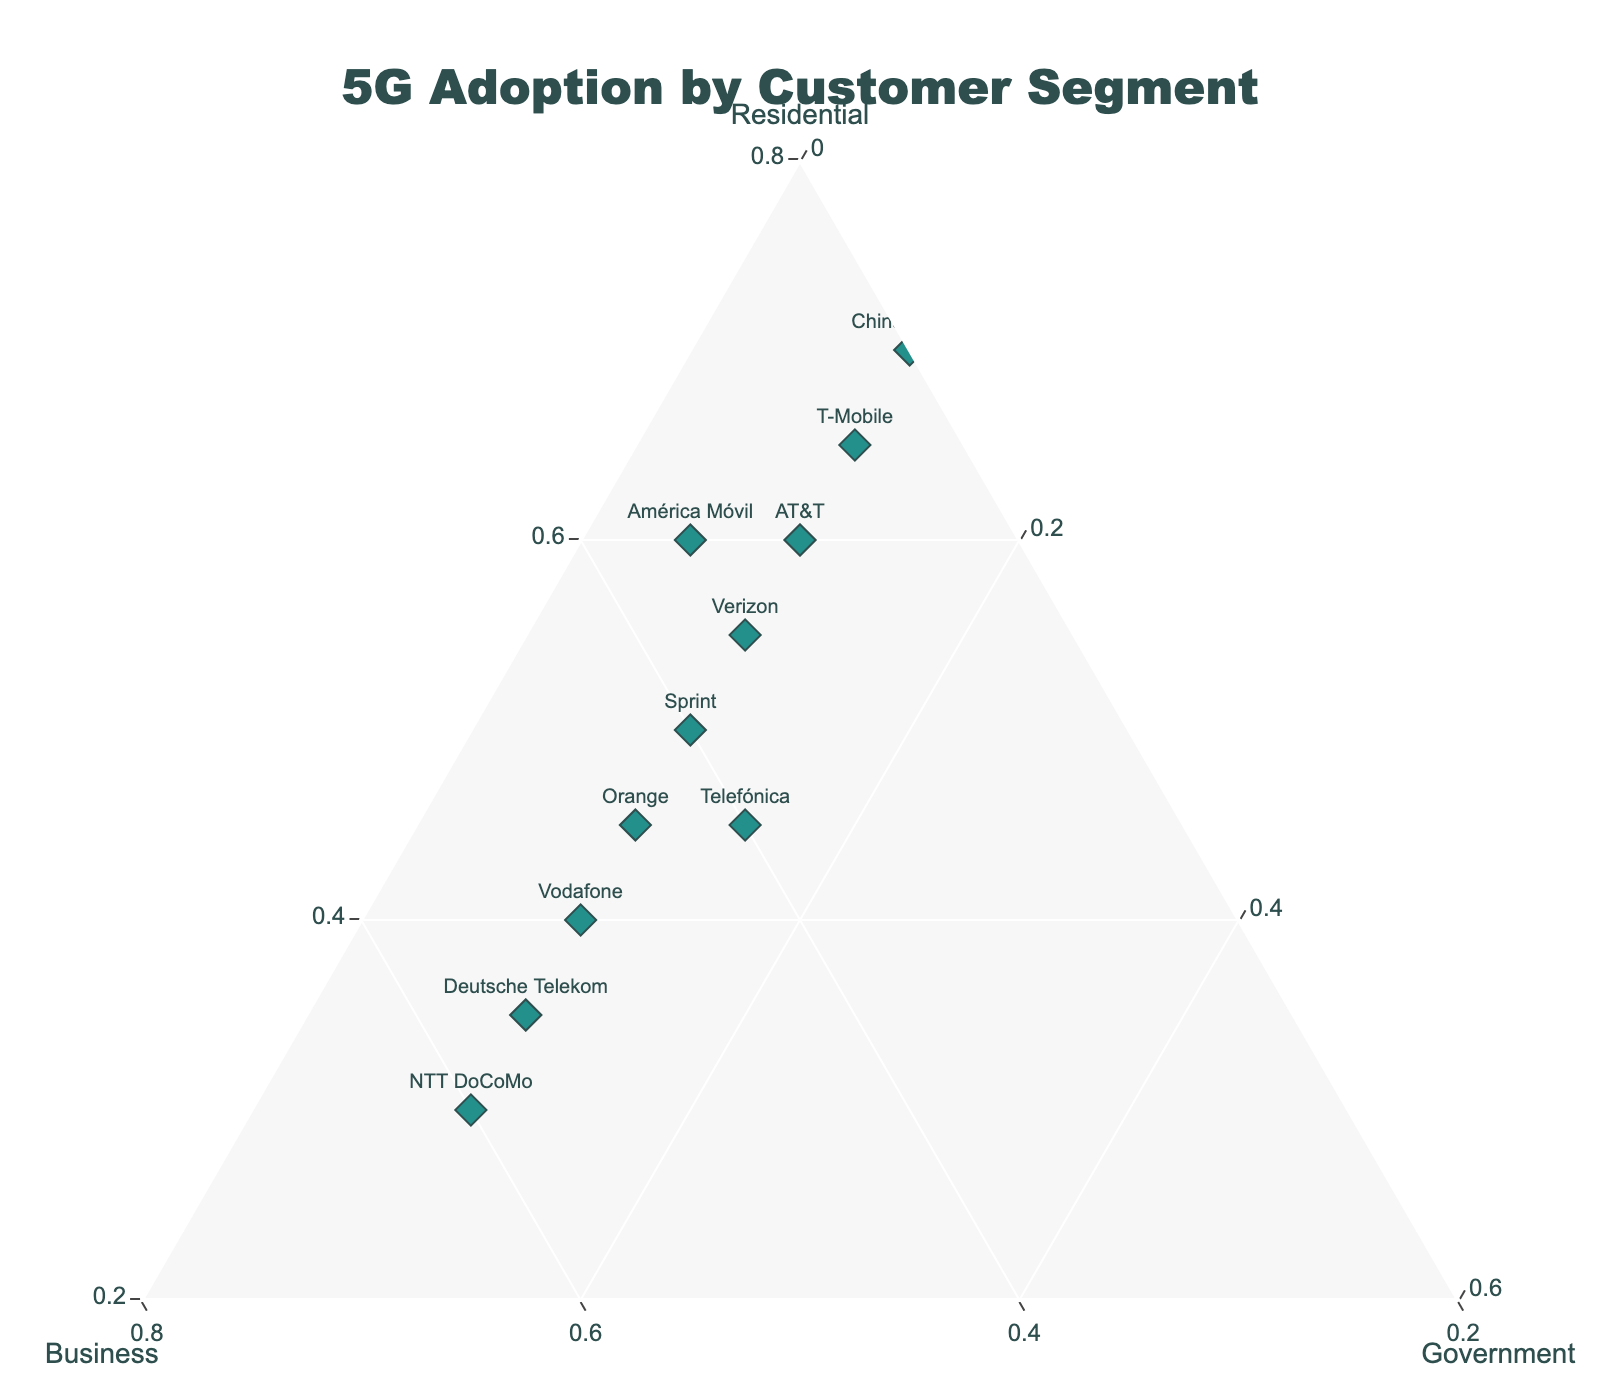Who has the highest percentage of residential 5G adoption? By observing the ternary plot, identify the point closest to the 'Residential' vertex. This point represents the company with the highest residential adoption.
Answer: Bharti Airtel Which company has the highest overall adoption of 5G, considering all segments? Sum up the Residential, Business, and Government adoption rates for each company and identify which point has the highest total value by the color intensity of the marker.
Answer: China Mobile Compare T-Mobile and Vodafone: Which company has a greater share in the business segment? Locate the points representing T-Mobile and Vodafone and observe their positions relative to the 'Business' axis. The one closer to the 'Business' vertex has a greater share.
Answer: Vodafone What is the sum percentage of government adoption across all companies? Since all the companies have the same government adoption rate, multiply 10% by the number of companies (12) in the ternary plot to get the total percentage.
Answer: 120% Are there any companies with a balanced distribution between residential and business segments? Look for points plotted midway between the 'Residential' and 'Business' vertices while equidistant from 'Government.' Points like Orange and Telefónica are more balanced.
Answer: Orange, Telefónica Which company is closest to the center of the ternary plot? The center of the ternary plot has equal contributions from all segments. The point that appears nearest to the center represents the company.
Answer: Telefónica Between Verizon, AT&T, and Sprint, which has the highest percentage of business adoption? Compare the positions of Verizon, AT&T, and Sprint relative to the 'Business' axis. The point closest to the axis has the highest business adoption.
Answer: Sprint Identify the company with the smallest adoption in business and government segments combined. Sum the business and government percentages for each company and locate the one with the smallest combined total in the plot.
Answer: Bharti Airtel 